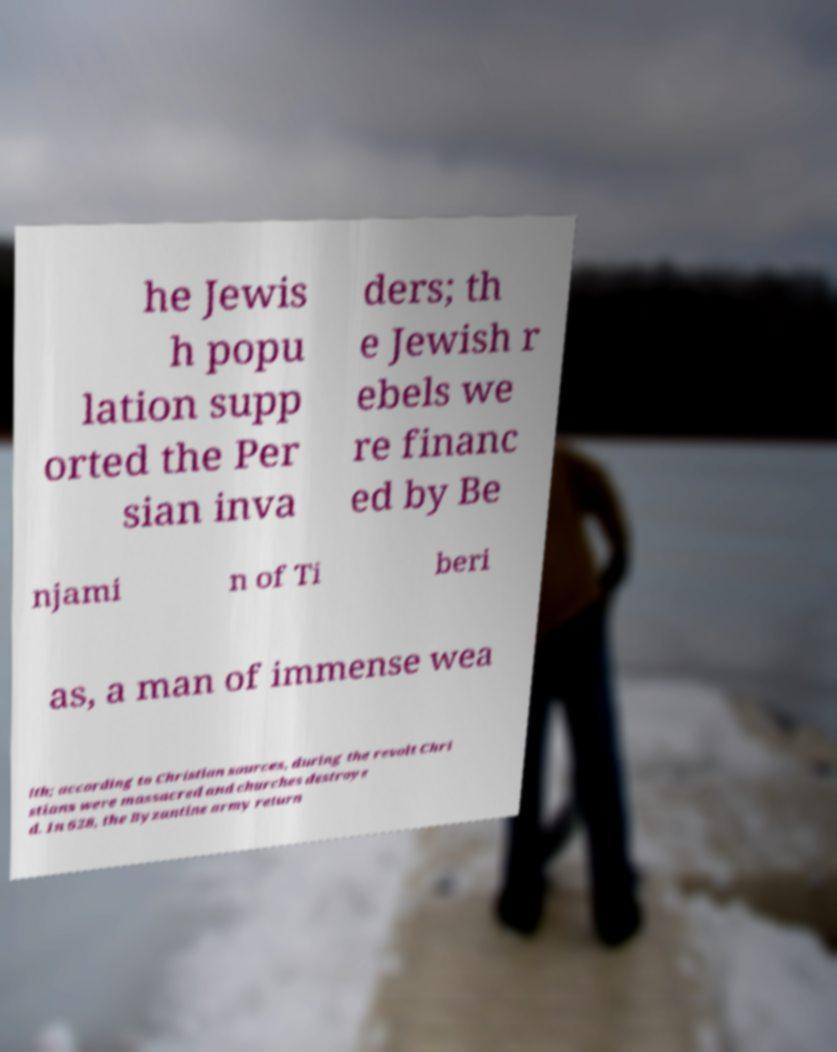Can you read and provide the text displayed in the image?This photo seems to have some interesting text. Can you extract and type it out for me? he Jewis h popu lation supp orted the Per sian inva ders; th e Jewish r ebels we re financ ed by Be njami n of Ti beri as, a man of immense wea lth; according to Christian sources, during the revolt Chri stians were massacred and churches destroye d. In 628, the Byzantine army return 